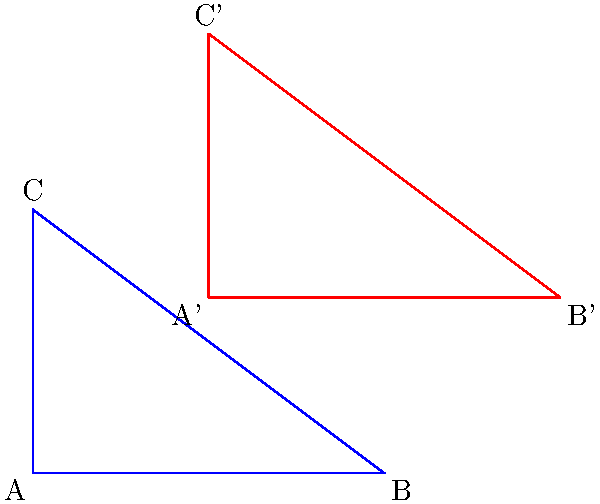A triangle ABC is transformed to create triangle A'B'C' as shown in the coordinate plane. If the area of triangle ABC is 6 square units, what is the area of triangle A'B'C'? How does this transformation affect the learning process in geometry, and what implications might it have for technology-enhanced learning tools? Let's approach this step-by-step:

1) First, we need to identify the transformation. By observing the coordinates, we can see that each point has been translated 2 units to the right and 2 units up. This is a translation, which preserves the shape and size of the original figure.

2) The area of a triangle can be calculated using the formula:
   $$\text{Area} = \frac{1}{2} \times \text{base} \times \text{height}$$

3) For triangle ABC:
   Base (AB) = 4 units
   Height (perpendicular from C to AB) = 3 units
   $$\text{Area of ABC} = \frac{1}{2} \times 4 \times 3 = 6 \text{ square units}$$

4) Since translation preserves the shape and size, triangle A'B'C' will have the same area as triangle ABC.

5) Therefore, the area of triangle A'B'C' is also 6 square units.

From a learning psychology perspective, this problem demonstrates several important concepts:

a) Spatial reasoning: Students must visualize and understand the transformation in space.

b) Invariance: The concept that certain properties (like area) remain unchanged under specific transformations.

c) Abstract thinking: Connecting geometric concepts with algebraic representations.

For technology-enhanced learning tools, this problem highlights the potential for:

1) Interactive visualizations: Tools that allow students to manipulate shapes and see the effects in real-time.

2) Adaptive learning: Systems that can generate similar problems with varying difficulty based on student performance.

3) Multisensory learning: Combining visual, kinesthetic, and analytical approaches to reinforce understanding.

4) Data analytics: Tracking student interactions with such problems to identify areas of strength and weakness in geometric reasoning.

By engaging with such problems through technology, students can develop a deeper, more intuitive understanding of geometric transformations and their properties.
Answer: 6 square units 